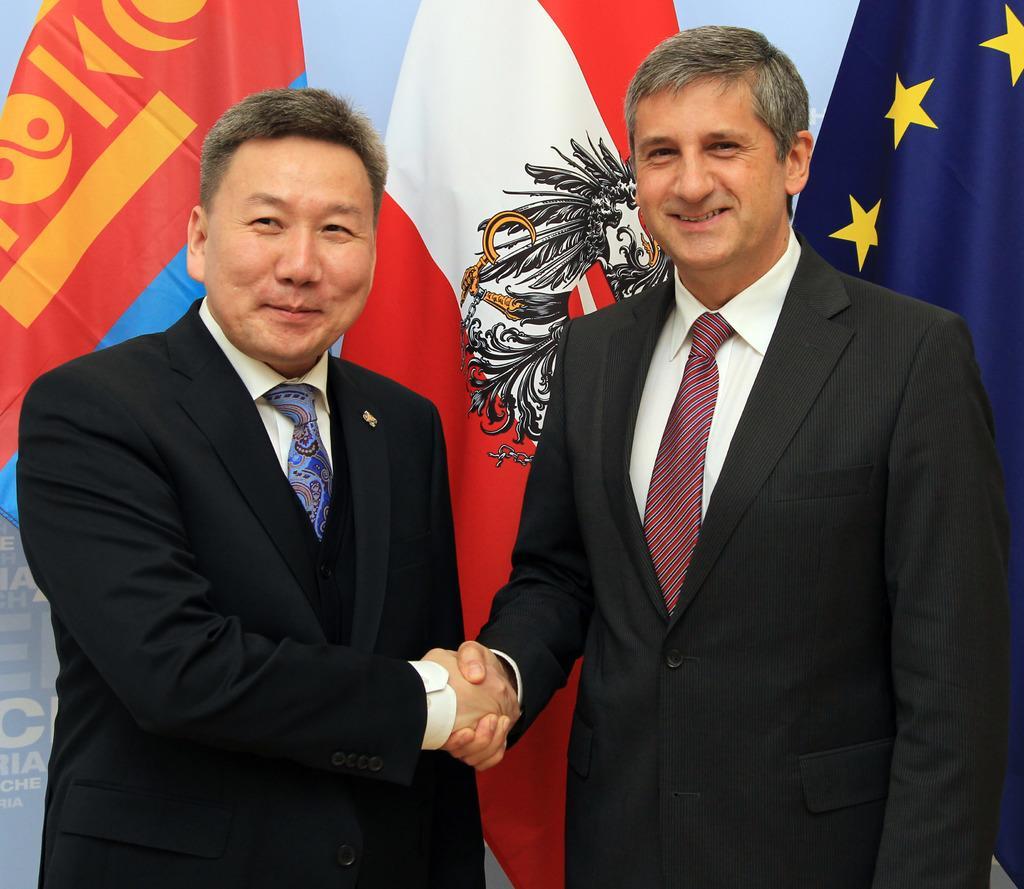In one or two sentences, can you explain what this image depicts? In the background we can see the flags. In this picture we can see the men wearing blazers and they are shaking their hands. They all are smiling. 